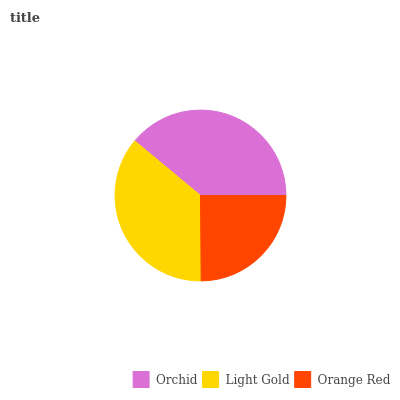Is Orange Red the minimum?
Answer yes or no. Yes. Is Orchid the maximum?
Answer yes or no. Yes. Is Light Gold the minimum?
Answer yes or no. No. Is Light Gold the maximum?
Answer yes or no. No. Is Orchid greater than Light Gold?
Answer yes or no. Yes. Is Light Gold less than Orchid?
Answer yes or no. Yes. Is Light Gold greater than Orchid?
Answer yes or no. No. Is Orchid less than Light Gold?
Answer yes or no. No. Is Light Gold the high median?
Answer yes or no. Yes. Is Light Gold the low median?
Answer yes or no. Yes. Is Orange Red the high median?
Answer yes or no. No. Is Orchid the low median?
Answer yes or no. No. 